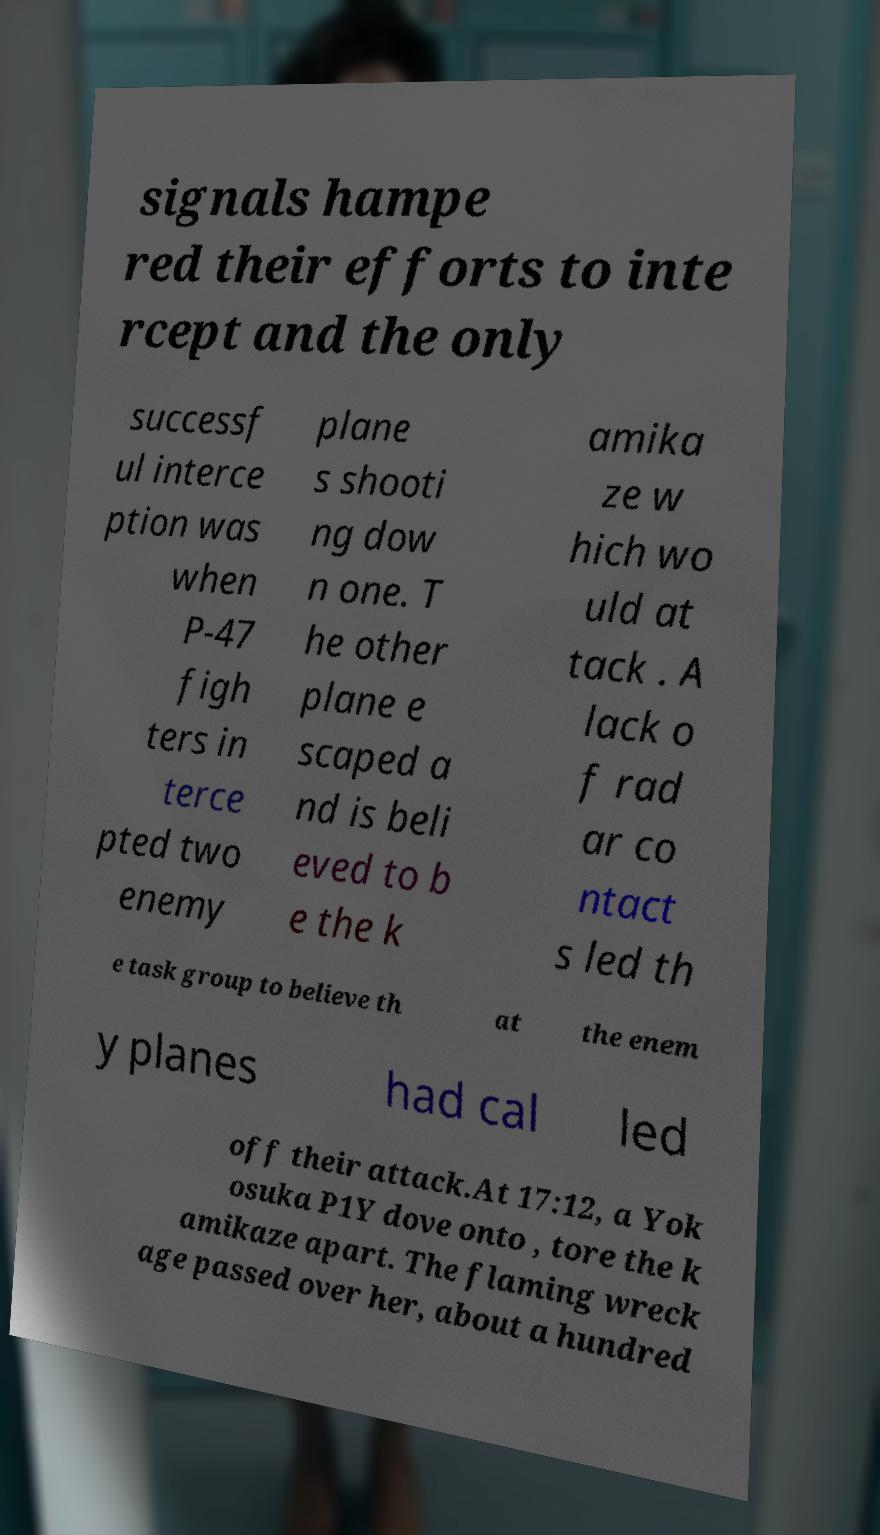Please read and relay the text visible in this image. What does it say? signals hampe red their efforts to inte rcept and the only successf ul interce ption was when P-47 figh ters in terce pted two enemy plane s shooti ng dow n one. T he other plane e scaped a nd is beli eved to b e the k amika ze w hich wo uld at tack . A lack o f rad ar co ntact s led th e task group to believe th at the enem y planes had cal led off their attack.At 17:12, a Yok osuka P1Y dove onto , tore the k amikaze apart. The flaming wreck age passed over her, about a hundred 